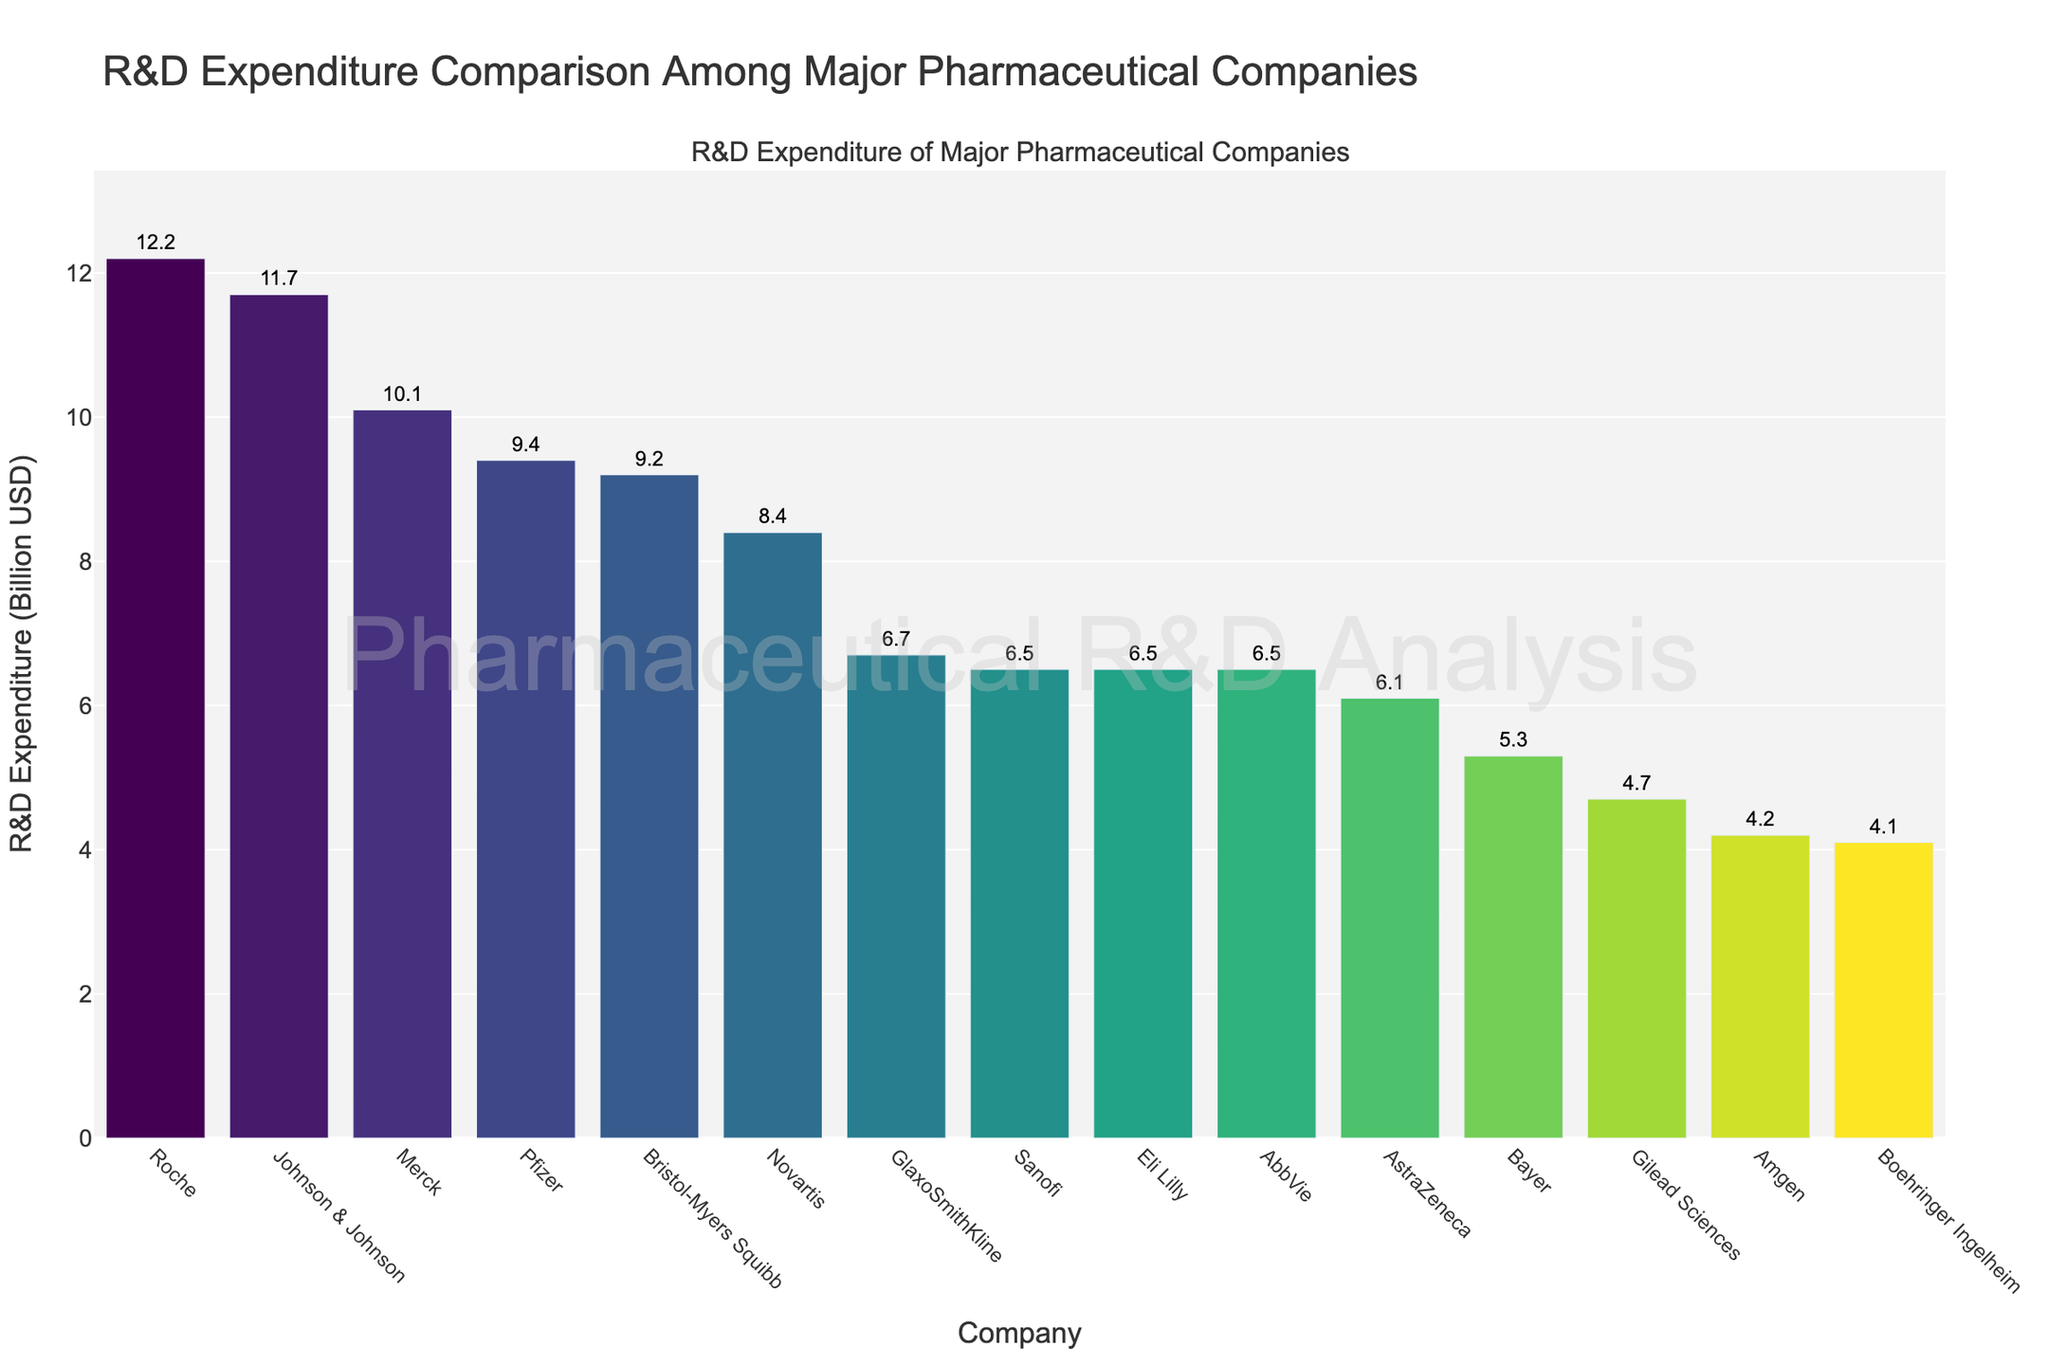Which company has the highest R&D expenditure? Pfizer has the highest R&D expenditure of $12.2 billion, shown as the tallest bar on the far left side of the chart.
Answer: Roche Which company has the lowest R&D expenditure? The lowest R&D expenditure is labeled at the shortest bar on the chart, indicating Boehringer Ingelheim with $4.1 billion.
Answer: Boehringer Ingelheim How much more does Roche spend on R&D compared to Pfizer? Roche's R&D expenditure is $12.2 billion, and Pfizer's is $9.4 billion. The difference is $12.2 - $9.4 = $2.8 billion.
Answer: $2.8 billion What is the total R&D expenditure of Johnson & Johnson, Merck, and Novartis combined? The total R&D expenditure for these companies is the sum of their individual expenditures: Johnson & Johnson ($11.7 billion), Merck ($10.1 billion), and Novartis ($8.4 billion). Thus, $11.7 + $10.1 + $8.4 = $30.2 billion.
Answer: $30.2 billion Which companies have an R&D expenditure greater than $8 billion but less than $10 billion? The companies that fall within the $8 - $10 billion range are Pfizer ($9.4 billion) and Novartis ($8.4 billion).
Answer: Pfizer, Novartis What is the average R&D expenditure of the top 5 companies? The top 5 companies are Roche ($12.2 billion), Johnson & Johnson ($11.7 billion), Merck ($10.1 billion), Pfizer ($9.4 billion), and Bristol-Myers Squibb ($9.2 billion). The average is calculated as ($12.2 + $11.7 + $10.1 + $9.4 + $9.2) / 5 = $10.52 billion.
Answer: $10.52 billion Which company has an R&D expenditure that is approximately half of that of Pfizer? Pfizer's R&D expenditure is $9.4 billion. Half of $9.4 billion is $4.7 billion. The company closest to $4.7 billion is Gilead Sciences with $4.7 billion.
Answer: Gilead Sciences What is the combined R&D expenditure of the companies with expenditures less than $5 billion? The companies with expenditures less than $5 billion are Amgen ($4.2 billion), Gilead Sciences ($4.7 billion), and Boehringer Ingelheim ($4.1 billion). The combined expenditure is $4.2 + $4.7 + $4.1 = $13 billion.
Answer: $13 billion 